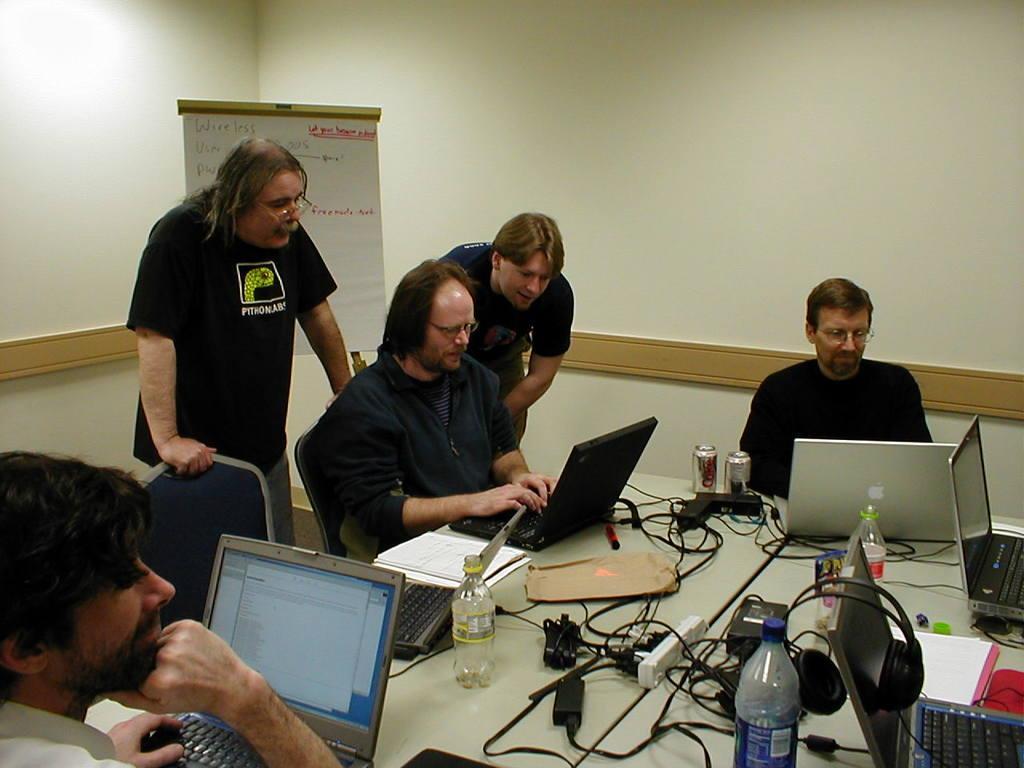Describe this image in one or two sentences. In this image I can see the group of people. Among them two people are standing. In front of them there is a laptop,bottle,headset,tin,papers etc. At the backside of this person there is a board and something written on it. And at the background of these people there is a wall. 